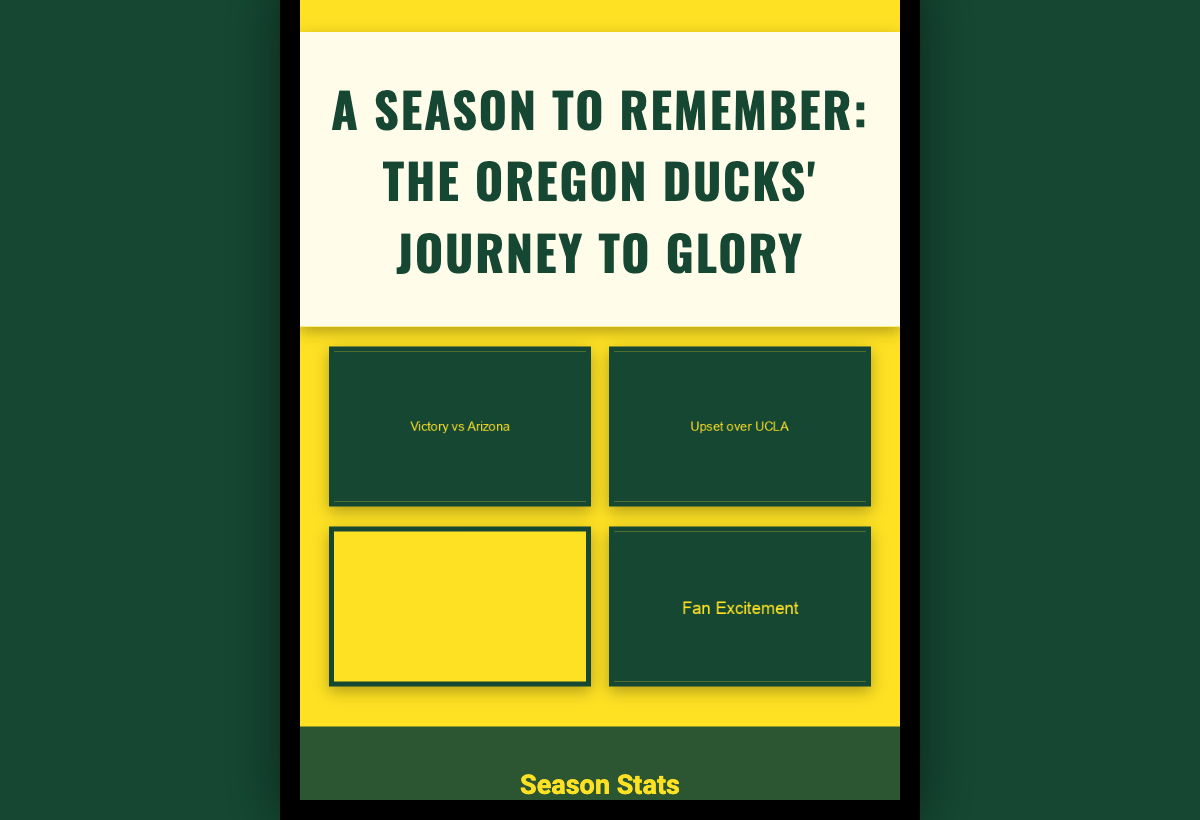what is the title of the book? The title is prominently displayed at the top of the cover.
Answer: A Season to Remember: The Oregon Ducks' Journey to Glory how many wins did the Oregon Ducks have this season? The number of wins is listed in the season stats section.
Answer: 29 who is featured as a standout player on the cover? The player names and statistics are included in the player sections.
Answer: Payton Pritchard what is the team color used in the book cover? The background color and design elements reflect the team's color.
Answer: Green what is the average points per game (PPG) for the season? The PPG is provided in the stats section of the cover.
Answer: 78.4 what type of moments are shown in the collage? The collage features various pivotal moments from the season.
Answer: Triumphant moments how many players are showcased on the cover? The number of players is indicated in the player section.
Answer: 2 which player's position is listed as "Guard"? The position is specified next to each player's name.
Answer: Payton Pritchard what imagery is used to enhance the excitement of the cover? The imagery includes action shots and fan reactions.
Answer: Intense game moments 